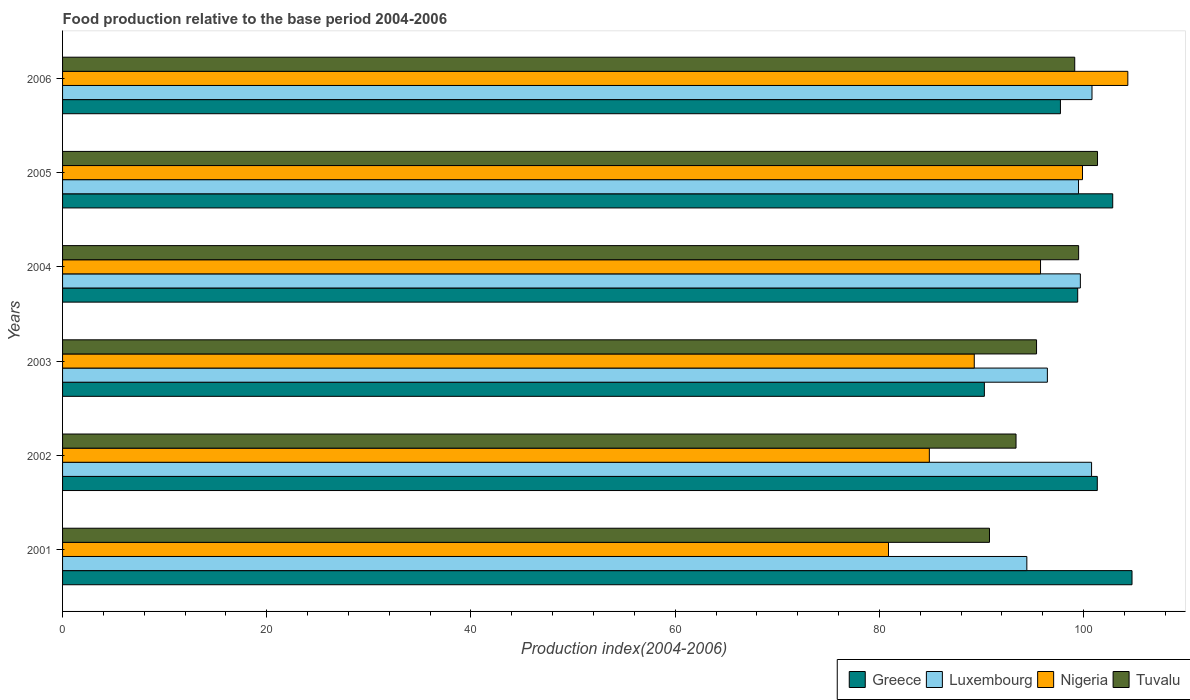Are the number of bars per tick equal to the number of legend labels?
Keep it short and to the point. Yes. Are the number of bars on each tick of the Y-axis equal?
Your response must be concise. Yes. What is the food production index in Nigeria in 2003?
Keep it short and to the point. 89.29. Across all years, what is the maximum food production index in Greece?
Offer a very short reply. 104.74. Across all years, what is the minimum food production index in Nigeria?
Offer a very short reply. 80.89. In which year was the food production index in Greece minimum?
Provide a short and direct response. 2003. What is the total food production index in Tuvalu in the graph?
Your answer should be very brief. 579.55. What is the difference between the food production index in Tuvalu in 2002 and that in 2003?
Give a very brief answer. -2.01. What is the difference between the food production index in Nigeria in 2006 and the food production index in Tuvalu in 2001?
Your response must be concise. 13.55. What is the average food production index in Greece per year?
Ensure brevity in your answer.  99.39. In the year 2006, what is the difference between the food production index in Tuvalu and food production index in Luxembourg?
Ensure brevity in your answer.  -1.69. In how many years, is the food production index in Nigeria greater than 52 ?
Your answer should be very brief. 6. What is the ratio of the food production index in Luxembourg in 2002 to that in 2004?
Offer a very short reply. 1.01. Is the difference between the food production index in Tuvalu in 2004 and 2005 greater than the difference between the food production index in Luxembourg in 2004 and 2005?
Keep it short and to the point. No. What is the difference between the highest and the second highest food production index in Luxembourg?
Give a very brief answer. 0.04. What is the difference between the highest and the lowest food production index in Luxembourg?
Keep it short and to the point. 6.38. What does the 4th bar from the top in 2004 represents?
Your response must be concise. Greece. What does the 1st bar from the bottom in 2004 represents?
Offer a terse response. Greece. Is it the case that in every year, the sum of the food production index in Nigeria and food production index in Greece is greater than the food production index in Luxembourg?
Provide a succinct answer. Yes. How many bars are there?
Provide a short and direct response. 24. Are all the bars in the graph horizontal?
Offer a terse response. Yes. How many years are there in the graph?
Provide a succinct answer. 6. What is the difference between two consecutive major ticks on the X-axis?
Your answer should be compact. 20. Does the graph contain any zero values?
Provide a short and direct response. No. Does the graph contain grids?
Provide a short and direct response. No. Where does the legend appear in the graph?
Keep it short and to the point. Bottom right. How many legend labels are there?
Give a very brief answer. 4. What is the title of the graph?
Your answer should be very brief. Food production relative to the base period 2004-2006. What is the label or title of the X-axis?
Provide a short and direct response. Production index(2004-2006). What is the label or title of the Y-axis?
Keep it short and to the point. Years. What is the Production index(2004-2006) of Greece in 2001?
Provide a short and direct response. 104.74. What is the Production index(2004-2006) in Luxembourg in 2001?
Your answer should be very brief. 94.44. What is the Production index(2004-2006) in Nigeria in 2001?
Offer a very short reply. 80.89. What is the Production index(2004-2006) of Tuvalu in 2001?
Offer a very short reply. 90.78. What is the Production index(2004-2006) of Greece in 2002?
Ensure brevity in your answer.  101.34. What is the Production index(2004-2006) of Luxembourg in 2002?
Provide a succinct answer. 100.78. What is the Production index(2004-2006) of Nigeria in 2002?
Offer a very short reply. 84.89. What is the Production index(2004-2006) in Tuvalu in 2002?
Provide a short and direct response. 93.38. What is the Production index(2004-2006) in Greece in 2003?
Offer a very short reply. 90.28. What is the Production index(2004-2006) of Luxembourg in 2003?
Provide a succinct answer. 96.45. What is the Production index(2004-2006) in Nigeria in 2003?
Your response must be concise. 89.29. What is the Production index(2004-2006) in Tuvalu in 2003?
Provide a short and direct response. 95.39. What is the Production index(2004-2006) of Greece in 2004?
Make the answer very short. 99.42. What is the Production index(2004-2006) of Luxembourg in 2004?
Your response must be concise. 99.68. What is the Production index(2004-2006) in Nigeria in 2004?
Keep it short and to the point. 95.78. What is the Production index(2004-2006) of Tuvalu in 2004?
Provide a succinct answer. 99.51. What is the Production index(2004-2006) of Greece in 2005?
Your response must be concise. 102.85. What is the Production index(2004-2006) of Luxembourg in 2005?
Give a very brief answer. 99.5. What is the Production index(2004-2006) in Nigeria in 2005?
Your answer should be compact. 99.89. What is the Production index(2004-2006) of Tuvalu in 2005?
Keep it short and to the point. 101.36. What is the Production index(2004-2006) in Greece in 2006?
Keep it short and to the point. 97.73. What is the Production index(2004-2006) of Luxembourg in 2006?
Ensure brevity in your answer.  100.82. What is the Production index(2004-2006) of Nigeria in 2006?
Keep it short and to the point. 104.33. What is the Production index(2004-2006) of Tuvalu in 2006?
Offer a very short reply. 99.13. Across all years, what is the maximum Production index(2004-2006) of Greece?
Give a very brief answer. 104.74. Across all years, what is the maximum Production index(2004-2006) of Luxembourg?
Offer a very short reply. 100.82. Across all years, what is the maximum Production index(2004-2006) in Nigeria?
Make the answer very short. 104.33. Across all years, what is the maximum Production index(2004-2006) in Tuvalu?
Your answer should be compact. 101.36. Across all years, what is the minimum Production index(2004-2006) of Greece?
Your response must be concise. 90.28. Across all years, what is the minimum Production index(2004-2006) in Luxembourg?
Offer a terse response. 94.44. Across all years, what is the minimum Production index(2004-2006) in Nigeria?
Your answer should be compact. 80.89. Across all years, what is the minimum Production index(2004-2006) in Tuvalu?
Your answer should be very brief. 90.78. What is the total Production index(2004-2006) of Greece in the graph?
Your answer should be very brief. 596.36. What is the total Production index(2004-2006) in Luxembourg in the graph?
Your answer should be compact. 591.67. What is the total Production index(2004-2006) of Nigeria in the graph?
Keep it short and to the point. 555.07. What is the total Production index(2004-2006) of Tuvalu in the graph?
Provide a succinct answer. 579.55. What is the difference between the Production index(2004-2006) in Greece in 2001 and that in 2002?
Offer a terse response. 3.4. What is the difference between the Production index(2004-2006) of Luxembourg in 2001 and that in 2002?
Your response must be concise. -6.34. What is the difference between the Production index(2004-2006) in Greece in 2001 and that in 2003?
Your answer should be very brief. 14.46. What is the difference between the Production index(2004-2006) of Luxembourg in 2001 and that in 2003?
Your response must be concise. -2.01. What is the difference between the Production index(2004-2006) in Nigeria in 2001 and that in 2003?
Provide a succinct answer. -8.4. What is the difference between the Production index(2004-2006) of Tuvalu in 2001 and that in 2003?
Give a very brief answer. -4.61. What is the difference between the Production index(2004-2006) of Greece in 2001 and that in 2004?
Your answer should be compact. 5.32. What is the difference between the Production index(2004-2006) of Luxembourg in 2001 and that in 2004?
Ensure brevity in your answer.  -5.24. What is the difference between the Production index(2004-2006) of Nigeria in 2001 and that in 2004?
Ensure brevity in your answer.  -14.89. What is the difference between the Production index(2004-2006) of Tuvalu in 2001 and that in 2004?
Your answer should be very brief. -8.73. What is the difference between the Production index(2004-2006) of Greece in 2001 and that in 2005?
Give a very brief answer. 1.89. What is the difference between the Production index(2004-2006) in Luxembourg in 2001 and that in 2005?
Your response must be concise. -5.06. What is the difference between the Production index(2004-2006) of Nigeria in 2001 and that in 2005?
Your answer should be compact. -19. What is the difference between the Production index(2004-2006) in Tuvalu in 2001 and that in 2005?
Your answer should be very brief. -10.58. What is the difference between the Production index(2004-2006) in Greece in 2001 and that in 2006?
Provide a succinct answer. 7.01. What is the difference between the Production index(2004-2006) in Luxembourg in 2001 and that in 2006?
Your answer should be very brief. -6.38. What is the difference between the Production index(2004-2006) of Nigeria in 2001 and that in 2006?
Your response must be concise. -23.44. What is the difference between the Production index(2004-2006) of Tuvalu in 2001 and that in 2006?
Make the answer very short. -8.35. What is the difference between the Production index(2004-2006) of Greece in 2002 and that in 2003?
Ensure brevity in your answer.  11.06. What is the difference between the Production index(2004-2006) in Luxembourg in 2002 and that in 2003?
Make the answer very short. 4.33. What is the difference between the Production index(2004-2006) in Nigeria in 2002 and that in 2003?
Offer a terse response. -4.4. What is the difference between the Production index(2004-2006) in Tuvalu in 2002 and that in 2003?
Provide a short and direct response. -2.01. What is the difference between the Production index(2004-2006) of Greece in 2002 and that in 2004?
Provide a succinct answer. 1.92. What is the difference between the Production index(2004-2006) of Luxembourg in 2002 and that in 2004?
Provide a succinct answer. 1.1. What is the difference between the Production index(2004-2006) in Nigeria in 2002 and that in 2004?
Offer a very short reply. -10.89. What is the difference between the Production index(2004-2006) of Tuvalu in 2002 and that in 2004?
Keep it short and to the point. -6.13. What is the difference between the Production index(2004-2006) of Greece in 2002 and that in 2005?
Offer a very short reply. -1.51. What is the difference between the Production index(2004-2006) of Luxembourg in 2002 and that in 2005?
Your answer should be compact. 1.28. What is the difference between the Production index(2004-2006) in Tuvalu in 2002 and that in 2005?
Make the answer very short. -7.98. What is the difference between the Production index(2004-2006) in Greece in 2002 and that in 2006?
Your response must be concise. 3.61. What is the difference between the Production index(2004-2006) in Luxembourg in 2002 and that in 2006?
Your response must be concise. -0.04. What is the difference between the Production index(2004-2006) of Nigeria in 2002 and that in 2006?
Provide a succinct answer. -19.44. What is the difference between the Production index(2004-2006) in Tuvalu in 2002 and that in 2006?
Ensure brevity in your answer.  -5.75. What is the difference between the Production index(2004-2006) in Greece in 2003 and that in 2004?
Give a very brief answer. -9.14. What is the difference between the Production index(2004-2006) in Luxembourg in 2003 and that in 2004?
Ensure brevity in your answer.  -3.23. What is the difference between the Production index(2004-2006) of Nigeria in 2003 and that in 2004?
Provide a short and direct response. -6.49. What is the difference between the Production index(2004-2006) of Tuvalu in 2003 and that in 2004?
Provide a short and direct response. -4.12. What is the difference between the Production index(2004-2006) in Greece in 2003 and that in 2005?
Give a very brief answer. -12.57. What is the difference between the Production index(2004-2006) of Luxembourg in 2003 and that in 2005?
Make the answer very short. -3.05. What is the difference between the Production index(2004-2006) of Nigeria in 2003 and that in 2005?
Keep it short and to the point. -10.6. What is the difference between the Production index(2004-2006) in Tuvalu in 2003 and that in 2005?
Your response must be concise. -5.97. What is the difference between the Production index(2004-2006) in Greece in 2003 and that in 2006?
Provide a succinct answer. -7.45. What is the difference between the Production index(2004-2006) of Luxembourg in 2003 and that in 2006?
Your answer should be very brief. -4.37. What is the difference between the Production index(2004-2006) in Nigeria in 2003 and that in 2006?
Your answer should be very brief. -15.04. What is the difference between the Production index(2004-2006) in Tuvalu in 2003 and that in 2006?
Offer a very short reply. -3.74. What is the difference between the Production index(2004-2006) in Greece in 2004 and that in 2005?
Your response must be concise. -3.43. What is the difference between the Production index(2004-2006) of Luxembourg in 2004 and that in 2005?
Your response must be concise. 0.18. What is the difference between the Production index(2004-2006) in Nigeria in 2004 and that in 2005?
Make the answer very short. -4.11. What is the difference between the Production index(2004-2006) of Tuvalu in 2004 and that in 2005?
Provide a succinct answer. -1.85. What is the difference between the Production index(2004-2006) of Greece in 2004 and that in 2006?
Your answer should be compact. 1.69. What is the difference between the Production index(2004-2006) of Luxembourg in 2004 and that in 2006?
Your answer should be compact. -1.14. What is the difference between the Production index(2004-2006) of Nigeria in 2004 and that in 2006?
Offer a very short reply. -8.55. What is the difference between the Production index(2004-2006) of Tuvalu in 2004 and that in 2006?
Keep it short and to the point. 0.38. What is the difference between the Production index(2004-2006) of Greece in 2005 and that in 2006?
Your response must be concise. 5.12. What is the difference between the Production index(2004-2006) in Luxembourg in 2005 and that in 2006?
Offer a very short reply. -1.32. What is the difference between the Production index(2004-2006) of Nigeria in 2005 and that in 2006?
Make the answer very short. -4.44. What is the difference between the Production index(2004-2006) of Tuvalu in 2005 and that in 2006?
Offer a very short reply. 2.23. What is the difference between the Production index(2004-2006) of Greece in 2001 and the Production index(2004-2006) of Luxembourg in 2002?
Keep it short and to the point. 3.96. What is the difference between the Production index(2004-2006) in Greece in 2001 and the Production index(2004-2006) in Nigeria in 2002?
Ensure brevity in your answer.  19.85. What is the difference between the Production index(2004-2006) in Greece in 2001 and the Production index(2004-2006) in Tuvalu in 2002?
Your answer should be very brief. 11.36. What is the difference between the Production index(2004-2006) in Luxembourg in 2001 and the Production index(2004-2006) in Nigeria in 2002?
Your answer should be compact. 9.55. What is the difference between the Production index(2004-2006) of Luxembourg in 2001 and the Production index(2004-2006) of Tuvalu in 2002?
Your response must be concise. 1.06. What is the difference between the Production index(2004-2006) in Nigeria in 2001 and the Production index(2004-2006) in Tuvalu in 2002?
Your response must be concise. -12.49. What is the difference between the Production index(2004-2006) of Greece in 2001 and the Production index(2004-2006) of Luxembourg in 2003?
Make the answer very short. 8.29. What is the difference between the Production index(2004-2006) of Greece in 2001 and the Production index(2004-2006) of Nigeria in 2003?
Give a very brief answer. 15.45. What is the difference between the Production index(2004-2006) in Greece in 2001 and the Production index(2004-2006) in Tuvalu in 2003?
Make the answer very short. 9.35. What is the difference between the Production index(2004-2006) in Luxembourg in 2001 and the Production index(2004-2006) in Nigeria in 2003?
Offer a terse response. 5.15. What is the difference between the Production index(2004-2006) of Luxembourg in 2001 and the Production index(2004-2006) of Tuvalu in 2003?
Provide a succinct answer. -0.95. What is the difference between the Production index(2004-2006) in Greece in 2001 and the Production index(2004-2006) in Luxembourg in 2004?
Offer a very short reply. 5.06. What is the difference between the Production index(2004-2006) in Greece in 2001 and the Production index(2004-2006) in Nigeria in 2004?
Give a very brief answer. 8.96. What is the difference between the Production index(2004-2006) of Greece in 2001 and the Production index(2004-2006) of Tuvalu in 2004?
Your response must be concise. 5.23. What is the difference between the Production index(2004-2006) in Luxembourg in 2001 and the Production index(2004-2006) in Nigeria in 2004?
Give a very brief answer. -1.34. What is the difference between the Production index(2004-2006) in Luxembourg in 2001 and the Production index(2004-2006) in Tuvalu in 2004?
Provide a succinct answer. -5.07. What is the difference between the Production index(2004-2006) of Nigeria in 2001 and the Production index(2004-2006) of Tuvalu in 2004?
Provide a short and direct response. -18.62. What is the difference between the Production index(2004-2006) in Greece in 2001 and the Production index(2004-2006) in Luxembourg in 2005?
Keep it short and to the point. 5.24. What is the difference between the Production index(2004-2006) in Greece in 2001 and the Production index(2004-2006) in Nigeria in 2005?
Ensure brevity in your answer.  4.85. What is the difference between the Production index(2004-2006) of Greece in 2001 and the Production index(2004-2006) of Tuvalu in 2005?
Ensure brevity in your answer.  3.38. What is the difference between the Production index(2004-2006) in Luxembourg in 2001 and the Production index(2004-2006) in Nigeria in 2005?
Offer a terse response. -5.45. What is the difference between the Production index(2004-2006) in Luxembourg in 2001 and the Production index(2004-2006) in Tuvalu in 2005?
Keep it short and to the point. -6.92. What is the difference between the Production index(2004-2006) of Nigeria in 2001 and the Production index(2004-2006) of Tuvalu in 2005?
Your answer should be very brief. -20.47. What is the difference between the Production index(2004-2006) in Greece in 2001 and the Production index(2004-2006) in Luxembourg in 2006?
Your response must be concise. 3.92. What is the difference between the Production index(2004-2006) in Greece in 2001 and the Production index(2004-2006) in Nigeria in 2006?
Make the answer very short. 0.41. What is the difference between the Production index(2004-2006) of Greece in 2001 and the Production index(2004-2006) of Tuvalu in 2006?
Provide a succinct answer. 5.61. What is the difference between the Production index(2004-2006) in Luxembourg in 2001 and the Production index(2004-2006) in Nigeria in 2006?
Ensure brevity in your answer.  -9.89. What is the difference between the Production index(2004-2006) of Luxembourg in 2001 and the Production index(2004-2006) of Tuvalu in 2006?
Your answer should be very brief. -4.69. What is the difference between the Production index(2004-2006) in Nigeria in 2001 and the Production index(2004-2006) in Tuvalu in 2006?
Make the answer very short. -18.24. What is the difference between the Production index(2004-2006) of Greece in 2002 and the Production index(2004-2006) of Luxembourg in 2003?
Make the answer very short. 4.89. What is the difference between the Production index(2004-2006) in Greece in 2002 and the Production index(2004-2006) in Nigeria in 2003?
Provide a short and direct response. 12.05. What is the difference between the Production index(2004-2006) of Greece in 2002 and the Production index(2004-2006) of Tuvalu in 2003?
Your response must be concise. 5.95. What is the difference between the Production index(2004-2006) of Luxembourg in 2002 and the Production index(2004-2006) of Nigeria in 2003?
Your response must be concise. 11.49. What is the difference between the Production index(2004-2006) of Luxembourg in 2002 and the Production index(2004-2006) of Tuvalu in 2003?
Make the answer very short. 5.39. What is the difference between the Production index(2004-2006) of Nigeria in 2002 and the Production index(2004-2006) of Tuvalu in 2003?
Your response must be concise. -10.5. What is the difference between the Production index(2004-2006) of Greece in 2002 and the Production index(2004-2006) of Luxembourg in 2004?
Offer a very short reply. 1.66. What is the difference between the Production index(2004-2006) in Greece in 2002 and the Production index(2004-2006) in Nigeria in 2004?
Offer a terse response. 5.56. What is the difference between the Production index(2004-2006) in Greece in 2002 and the Production index(2004-2006) in Tuvalu in 2004?
Make the answer very short. 1.83. What is the difference between the Production index(2004-2006) of Luxembourg in 2002 and the Production index(2004-2006) of Nigeria in 2004?
Keep it short and to the point. 5. What is the difference between the Production index(2004-2006) in Luxembourg in 2002 and the Production index(2004-2006) in Tuvalu in 2004?
Make the answer very short. 1.27. What is the difference between the Production index(2004-2006) of Nigeria in 2002 and the Production index(2004-2006) of Tuvalu in 2004?
Make the answer very short. -14.62. What is the difference between the Production index(2004-2006) of Greece in 2002 and the Production index(2004-2006) of Luxembourg in 2005?
Offer a very short reply. 1.84. What is the difference between the Production index(2004-2006) of Greece in 2002 and the Production index(2004-2006) of Nigeria in 2005?
Your answer should be very brief. 1.45. What is the difference between the Production index(2004-2006) of Greece in 2002 and the Production index(2004-2006) of Tuvalu in 2005?
Keep it short and to the point. -0.02. What is the difference between the Production index(2004-2006) of Luxembourg in 2002 and the Production index(2004-2006) of Nigeria in 2005?
Your response must be concise. 0.89. What is the difference between the Production index(2004-2006) of Luxembourg in 2002 and the Production index(2004-2006) of Tuvalu in 2005?
Make the answer very short. -0.58. What is the difference between the Production index(2004-2006) in Nigeria in 2002 and the Production index(2004-2006) in Tuvalu in 2005?
Provide a short and direct response. -16.47. What is the difference between the Production index(2004-2006) in Greece in 2002 and the Production index(2004-2006) in Luxembourg in 2006?
Your response must be concise. 0.52. What is the difference between the Production index(2004-2006) of Greece in 2002 and the Production index(2004-2006) of Nigeria in 2006?
Make the answer very short. -2.99. What is the difference between the Production index(2004-2006) of Greece in 2002 and the Production index(2004-2006) of Tuvalu in 2006?
Your response must be concise. 2.21. What is the difference between the Production index(2004-2006) in Luxembourg in 2002 and the Production index(2004-2006) in Nigeria in 2006?
Your response must be concise. -3.55. What is the difference between the Production index(2004-2006) in Luxembourg in 2002 and the Production index(2004-2006) in Tuvalu in 2006?
Offer a very short reply. 1.65. What is the difference between the Production index(2004-2006) in Nigeria in 2002 and the Production index(2004-2006) in Tuvalu in 2006?
Ensure brevity in your answer.  -14.24. What is the difference between the Production index(2004-2006) of Greece in 2003 and the Production index(2004-2006) of Tuvalu in 2004?
Ensure brevity in your answer.  -9.23. What is the difference between the Production index(2004-2006) of Luxembourg in 2003 and the Production index(2004-2006) of Nigeria in 2004?
Keep it short and to the point. 0.67. What is the difference between the Production index(2004-2006) of Luxembourg in 2003 and the Production index(2004-2006) of Tuvalu in 2004?
Make the answer very short. -3.06. What is the difference between the Production index(2004-2006) in Nigeria in 2003 and the Production index(2004-2006) in Tuvalu in 2004?
Keep it short and to the point. -10.22. What is the difference between the Production index(2004-2006) in Greece in 2003 and the Production index(2004-2006) in Luxembourg in 2005?
Offer a terse response. -9.22. What is the difference between the Production index(2004-2006) in Greece in 2003 and the Production index(2004-2006) in Nigeria in 2005?
Make the answer very short. -9.61. What is the difference between the Production index(2004-2006) in Greece in 2003 and the Production index(2004-2006) in Tuvalu in 2005?
Provide a succinct answer. -11.08. What is the difference between the Production index(2004-2006) in Luxembourg in 2003 and the Production index(2004-2006) in Nigeria in 2005?
Provide a succinct answer. -3.44. What is the difference between the Production index(2004-2006) of Luxembourg in 2003 and the Production index(2004-2006) of Tuvalu in 2005?
Give a very brief answer. -4.91. What is the difference between the Production index(2004-2006) in Nigeria in 2003 and the Production index(2004-2006) in Tuvalu in 2005?
Provide a short and direct response. -12.07. What is the difference between the Production index(2004-2006) of Greece in 2003 and the Production index(2004-2006) of Luxembourg in 2006?
Your answer should be very brief. -10.54. What is the difference between the Production index(2004-2006) of Greece in 2003 and the Production index(2004-2006) of Nigeria in 2006?
Provide a short and direct response. -14.05. What is the difference between the Production index(2004-2006) in Greece in 2003 and the Production index(2004-2006) in Tuvalu in 2006?
Provide a succinct answer. -8.85. What is the difference between the Production index(2004-2006) in Luxembourg in 2003 and the Production index(2004-2006) in Nigeria in 2006?
Your response must be concise. -7.88. What is the difference between the Production index(2004-2006) in Luxembourg in 2003 and the Production index(2004-2006) in Tuvalu in 2006?
Provide a succinct answer. -2.68. What is the difference between the Production index(2004-2006) of Nigeria in 2003 and the Production index(2004-2006) of Tuvalu in 2006?
Offer a terse response. -9.84. What is the difference between the Production index(2004-2006) in Greece in 2004 and the Production index(2004-2006) in Luxembourg in 2005?
Make the answer very short. -0.08. What is the difference between the Production index(2004-2006) of Greece in 2004 and the Production index(2004-2006) of Nigeria in 2005?
Your answer should be compact. -0.47. What is the difference between the Production index(2004-2006) in Greece in 2004 and the Production index(2004-2006) in Tuvalu in 2005?
Keep it short and to the point. -1.94. What is the difference between the Production index(2004-2006) in Luxembourg in 2004 and the Production index(2004-2006) in Nigeria in 2005?
Offer a very short reply. -0.21. What is the difference between the Production index(2004-2006) of Luxembourg in 2004 and the Production index(2004-2006) of Tuvalu in 2005?
Give a very brief answer. -1.68. What is the difference between the Production index(2004-2006) in Nigeria in 2004 and the Production index(2004-2006) in Tuvalu in 2005?
Offer a very short reply. -5.58. What is the difference between the Production index(2004-2006) in Greece in 2004 and the Production index(2004-2006) in Luxembourg in 2006?
Offer a terse response. -1.4. What is the difference between the Production index(2004-2006) of Greece in 2004 and the Production index(2004-2006) of Nigeria in 2006?
Your response must be concise. -4.91. What is the difference between the Production index(2004-2006) in Greece in 2004 and the Production index(2004-2006) in Tuvalu in 2006?
Keep it short and to the point. 0.29. What is the difference between the Production index(2004-2006) in Luxembourg in 2004 and the Production index(2004-2006) in Nigeria in 2006?
Keep it short and to the point. -4.65. What is the difference between the Production index(2004-2006) in Luxembourg in 2004 and the Production index(2004-2006) in Tuvalu in 2006?
Your answer should be very brief. 0.55. What is the difference between the Production index(2004-2006) of Nigeria in 2004 and the Production index(2004-2006) of Tuvalu in 2006?
Offer a terse response. -3.35. What is the difference between the Production index(2004-2006) in Greece in 2005 and the Production index(2004-2006) in Luxembourg in 2006?
Ensure brevity in your answer.  2.03. What is the difference between the Production index(2004-2006) in Greece in 2005 and the Production index(2004-2006) in Nigeria in 2006?
Your answer should be very brief. -1.48. What is the difference between the Production index(2004-2006) in Greece in 2005 and the Production index(2004-2006) in Tuvalu in 2006?
Make the answer very short. 3.72. What is the difference between the Production index(2004-2006) of Luxembourg in 2005 and the Production index(2004-2006) of Nigeria in 2006?
Offer a very short reply. -4.83. What is the difference between the Production index(2004-2006) in Luxembourg in 2005 and the Production index(2004-2006) in Tuvalu in 2006?
Give a very brief answer. 0.37. What is the difference between the Production index(2004-2006) of Nigeria in 2005 and the Production index(2004-2006) of Tuvalu in 2006?
Offer a terse response. 0.76. What is the average Production index(2004-2006) in Greece per year?
Your response must be concise. 99.39. What is the average Production index(2004-2006) in Luxembourg per year?
Keep it short and to the point. 98.61. What is the average Production index(2004-2006) in Nigeria per year?
Your answer should be compact. 92.51. What is the average Production index(2004-2006) in Tuvalu per year?
Give a very brief answer. 96.59. In the year 2001, what is the difference between the Production index(2004-2006) in Greece and Production index(2004-2006) in Nigeria?
Offer a terse response. 23.85. In the year 2001, what is the difference between the Production index(2004-2006) of Greece and Production index(2004-2006) of Tuvalu?
Your answer should be very brief. 13.96. In the year 2001, what is the difference between the Production index(2004-2006) of Luxembourg and Production index(2004-2006) of Nigeria?
Your response must be concise. 13.55. In the year 2001, what is the difference between the Production index(2004-2006) of Luxembourg and Production index(2004-2006) of Tuvalu?
Ensure brevity in your answer.  3.66. In the year 2001, what is the difference between the Production index(2004-2006) in Nigeria and Production index(2004-2006) in Tuvalu?
Make the answer very short. -9.89. In the year 2002, what is the difference between the Production index(2004-2006) of Greece and Production index(2004-2006) of Luxembourg?
Offer a terse response. 0.56. In the year 2002, what is the difference between the Production index(2004-2006) of Greece and Production index(2004-2006) of Nigeria?
Provide a succinct answer. 16.45. In the year 2002, what is the difference between the Production index(2004-2006) of Greece and Production index(2004-2006) of Tuvalu?
Your response must be concise. 7.96. In the year 2002, what is the difference between the Production index(2004-2006) in Luxembourg and Production index(2004-2006) in Nigeria?
Offer a very short reply. 15.89. In the year 2002, what is the difference between the Production index(2004-2006) in Nigeria and Production index(2004-2006) in Tuvalu?
Offer a very short reply. -8.49. In the year 2003, what is the difference between the Production index(2004-2006) of Greece and Production index(2004-2006) of Luxembourg?
Provide a succinct answer. -6.17. In the year 2003, what is the difference between the Production index(2004-2006) of Greece and Production index(2004-2006) of Tuvalu?
Offer a very short reply. -5.11. In the year 2003, what is the difference between the Production index(2004-2006) in Luxembourg and Production index(2004-2006) in Nigeria?
Make the answer very short. 7.16. In the year 2003, what is the difference between the Production index(2004-2006) of Luxembourg and Production index(2004-2006) of Tuvalu?
Your answer should be compact. 1.06. In the year 2004, what is the difference between the Production index(2004-2006) of Greece and Production index(2004-2006) of Luxembourg?
Your response must be concise. -0.26. In the year 2004, what is the difference between the Production index(2004-2006) of Greece and Production index(2004-2006) of Nigeria?
Your answer should be very brief. 3.64. In the year 2004, what is the difference between the Production index(2004-2006) of Greece and Production index(2004-2006) of Tuvalu?
Your answer should be very brief. -0.09. In the year 2004, what is the difference between the Production index(2004-2006) of Luxembourg and Production index(2004-2006) of Nigeria?
Offer a very short reply. 3.9. In the year 2004, what is the difference between the Production index(2004-2006) of Luxembourg and Production index(2004-2006) of Tuvalu?
Provide a succinct answer. 0.17. In the year 2004, what is the difference between the Production index(2004-2006) in Nigeria and Production index(2004-2006) in Tuvalu?
Give a very brief answer. -3.73. In the year 2005, what is the difference between the Production index(2004-2006) in Greece and Production index(2004-2006) in Luxembourg?
Offer a very short reply. 3.35. In the year 2005, what is the difference between the Production index(2004-2006) of Greece and Production index(2004-2006) of Nigeria?
Give a very brief answer. 2.96. In the year 2005, what is the difference between the Production index(2004-2006) in Greece and Production index(2004-2006) in Tuvalu?
Offer a terse response. 1.49. In the year 2005, what is the difference between the Production index(2004-2006) in Luxembourg and Production index(2004-2006) in Nigeria?
Provide a succinct answer. -0.39. In the year 2005, what is the difference between the Production index(2004-2006) in Luxembourg and Production index(2004-2006) in Tuvalu?
Give a very brief answer. -1.86. In the year 2005, what is the difference between the Production index(2004-2006) in Nigeria and Production index(2004-2006) in Tuvalu?
Keep it short and to the point. -1.47. In the year 2006, what is the difference between the Production index(2004-2006) in Greece and Production index(2004-2006) in Luxembourg?
Give a very brief answer. -3.09. In the year 2006, what is the difference between the Production index(2004-2006) of Greece and Production index(2004-2006) of Nigeria?
Give a very brief answer. -6.6. In the year 2006, what is the difference between the Production index(2004-2006) in Greece and Production index(2004-2006) in Tuvalu?
Offer a terse response. -1.4. In the year 2006, what is the difference between the Production index(2004-2006) in Luxembourg and Production index(2004-2006) in Nigeria?
Your response must be concise. -3.51. In the year 2006, what is the difference between the Production index(2004-2006) in Luxembourg and Production index(2004-2006) in Tuvalu?
Provide a short and direct response. 1.69. In the year 2006, what is the difference between the Production index(2004-2006) in Nigeria and Production index(2004-2006) in Tuvalu?
Provide a succinct answer. 5.2. What is the ratio of the Production index(2004-2006) of Greece in 2001 to that in 2002?
Your answer should be compact. 1.03. What is the ratio of the Production index(2004-2006) in Luxembourg in 2001 to that in 2002?
Your answer should be very brief. 0.94. What is the ratio of the Production index(2004-2006) in Nigeria in 2001 to that in 2002?
Provide a succinct answer. 0.95. What is the ratio of the Production index(2004-2006) in Tuvalu in 2001 to that in 2002?
Your answer should be very brief. 0.97. What is the ratio of the Production index(2004-2006) of Greece in 2001 to that in 2003?
Give a very brief answer. 1.16. What is the ratio of the Production index(2004-2006) of Luxembourg in 2001 to that in 2003?
Your answer should be very brief. 0.98. What is the ratio of the Production index(2004-2006) in Nigeria in 2001 to that in 2003?
Ensure brevity in your answer.  0.91. What is the ratio of the Production index(2004-2006) in Tuvalu in 2001 to that in 2003?
Make the answer very short. 0.95. What is the ratio of the Production index(2004-2006) of Greece in 2001 to that in 2004?
Ensure brevity in your answer.  1.05. What is the ratio of the Production index(2004-2006) in Nigeria in 2001 to that in 2004?
Your response must be concise. 0.84. What is the ratio of the Production index(2004-2006) in Tuvalu in 2001 to that in 2004?
Ensure brevity in your answer.  0.91. What is the ratio of the Production index(2004-2006) of Greece in 2001 to that in 2005?
Make the answer very short. 1.02. What is the ratio of the Production index(2004-2006) of Luxembourg in 2001 to that in 2005?
Your response must be concise. 0.95. What is the ratio of the Production index(2004-2006) in Nigeria in 2001 to that in 2005?
Keep it short and to the point. 0.81. What is the ratio of the Production index(2004-2006) in Tuvalu in 2001 to that in 2005?
Provide a short and direct response. 0.9. What is the ratio of the Production index(2004-2006) in Greece in 2001 to that in 2006?
Your answer should be compact. 1.07. What is the ratio of the Production index(2004-2006) in Luxembourg in 2001 to that in 2006?
Your answer should be very brief. 0.94. What is the ratio of the Production index(2004-2006) of Nigeria in 2001 to that in 2006?
Ensure brevity in your answer.  0.78. What is the ratio of the Production index(2004-2006) of Tuvalu in 2001 to that in 2006?
Make the answer very short. 0.92. What is the ratio of the Production index(2004-2006) in Greece in 2002 to that in 2003?
Ensure brevity in your answer.  1.12. What is the ratio of the Production index(2004-2006) of Luxembourg in 2002 to that in 2003?
Give a very brief answer. 1.04. What is the ratio of the Production index(2004-2006) in Nigeria in 2002 to that in 2003?
Provide a succinct answer. 0.95. What is the ratio of the Production index(2004-2006) in Tuvalu in 2002 to that in 2003?
Keep it short and to the point. 0.98. What is the ratio of the Production index(2004-2006) in Greece in 2002 to that in 2004?
Give a very brief answer. 1.02. What is the ratio of the Production index(2004-2006) in Luxembourg in 2002 to that in 2004?
Make the answer very short. 1.01. What is the ratio of the Production index(2004-2006) in Nigeria in 2002 to that in 2004?
Your response must be concise. 0.89. What is the ratio of the Production index(2004-2006) of Tuvalu in 2002 to that in 2004?
Offer a terse response. 0.94. What is the ratio of the Production index(2004-2006) in Greece in 2002 to that in 2005?
Offer a terse response. 0.99. What is the ratio of the Production index(2004-2006) in Luxembourg in 2002 to that in 2005?
Ensure brevity in your answer.  1.01. What is the ratio of the Production index(2004-2006) in Nigeria in 2002 to that in 2005?
Offer a very short reply. 0.85. What is the ratio of the Production index(2004-2006) in Tuvalu in 2002 to that in 2005?
Offer a very short reply. 0.92. What is the ratio of the Production index(2004-2006) in Greece in 2002 to that in 2006?
Provide a short and direct response. 1.04. What is the ratio of the Production index(2004-2006) in Luxembourg in 2002 to that in 2006?
Provide a short and direct response. 1. What is the ratio of the Production index(2004-2006) in Nigeria in 2002 to that in 2006?
Your answer should be very brief. 0.81. What is the ratio of the Production index(2004-2006) of Tuvalu in 2002 to that in 2006?
Provide a short and direct response. 0.94. What is the ratio of the Production index(2004-2006) in Greece in 2003 to that in 2004?
Your response must be concise. 0.91. What is the ratio of the Production index(2004-2006) in Luxembourg in 2003 to that in 2004?
Your response must be concise. 0.97. What is the ratio of the Production index(2004-2006) of Nigeria in 2003 to that in 2004?
Your answer should be very brief. 0.93. What is the ratio of the Production index(2004-2006) of Tuvalu in 2003 to that in 2004?
Ensure brevity in your answer.  0.96. What is the ratio of the Production index(2004-2006) in Greece in 2003 to that in 2005?
Provide a succinct answer. 0.88. What is the ratio of the Production index(2004-2006) of Luxembourg in 2003 to that in 2005?
Give a very brief answer. 0.97. What is the ratio of the Production index(2004-2006) of Nigeria in 2003 to that in 2005?
Your answer should be compact. 0.89. What is the ratio of the Production index(2004-2006) in Tuvalu in 2003 to that in 2005?
Your answer should be compact. 0.94. What is the ratio of the Production index(2004-2006) of Greece in 2003 to that in 2006?
Offer a terse response. 0.92. What is the ratio of the Production index(2004-2006) of Luxembourg in 2003 to that in 2006?
Your answer should be compact. 0.96. What is the ratio of the Production index(2004-2006) of Nigeria in 2003 to that in 2006?
Ensure brevity in your answer.  0.86. What is the ratio of the Production index(2004-2006) in Tuvalu in 2003 to that in 2006?
Offer a terse response. 0.96. What is the ratio of the Production index(2004-2006) in Greece in 2004 to that in 2005?
Your answer should be very brief. 0.97. What is the ratio of the Production index(2004-2006) of Luxembourg in 2004 to that in 2005?
Your response must be concise. 1. What is the ratio of the Production index(2004-2006) in Nigeria in 2004 to that in 2005?
Keep it short and to the point. 0.96. What is the ratio of the Production index(2004-2006) of Tuvalu in 2004 to that in 2005?
Your answer should be compact. 0.98. What is the ratio of the Production index(2004-2006) in Greece in 2004 to that in 2006?
Make the answer very short. 1.02. What is the ratio of the Production index(2004-2006) of Luxembourg in 2004 to that in 2006?
Offer a terse response. 0.99. What is the ratio of the Production index(2004-2006) of Nigeria in 2004 to that in 2006?
Keep it short and to the point. 0.92. What is the ratio of the Production index(2004-2006) in Greece in 2005 to that in 2006?
Your answer should be compact. 1.05. What is the ratio of the Production index(2004-2006) of Luxembourg in 2005 to that in 2006?
Provide a short and direct response. 0.99. What is the ratio of the Production index(2004-2006) of Nigeria in 2005 to that in 2006?
Your answer should be very brief. 0.96. What is the ratio of the Production index(2004-2006) of Tuvalu in 2005 to that in 2006?
Provide a short and direct response. 1.02. What is the difference between the highest and the second highest Production index(2004-2006) of Greece?
Ensure brevity in your answer.  1.89. What is the difference between the highest and the second highest Production index(2004-2006) of Luxembourg?
Ensure brevity in your answer.  0.04. What is the difference between the highest and the second highest Production index(2004-2006) in Nigeria?
Your response must be concise. 4.44. What is the difference between the highest and the second highest Production index(2004-2006) in Tuvalu?
Your answer should be compact. 1.85. What is the difference between the highest and the lowest Production index(2004-2006) of Greece?
Offer a very short reply. 14.46. What is the difference between the highest and the lowest Production index(2004-2006) in Luxembourg?
Keep it short and to the point. 6.38. What is the difference between the highest and the lowest Production index(2004-2006) in Nigeria?
Make the answer very short. 23.44. What is the difference between the highest and the lowest Production index(2004-2006) in Tuvalu?
Provide a short and direct response. 10.58. 